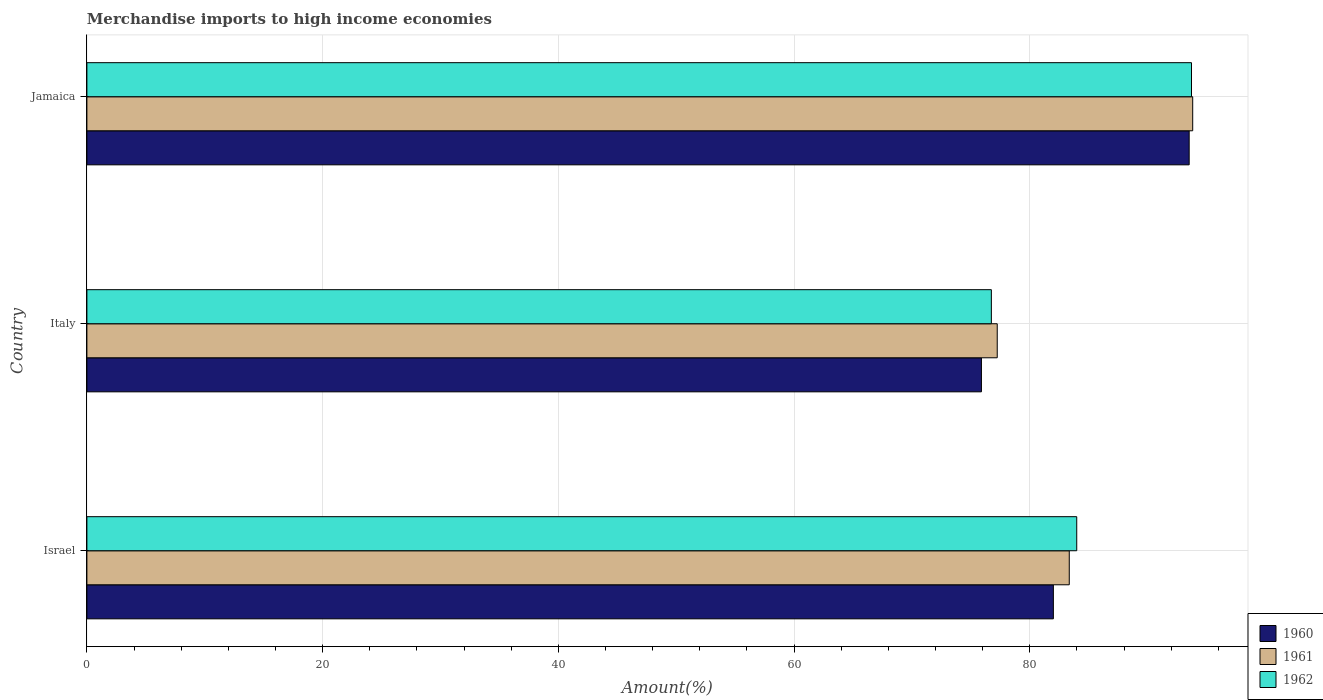How many groups of bars are there?
Offer a very short reply. 3. What is the percentage of amount earned from merchandise imports in 1961 in Israel?
Ensure brevity in your answer.  83.35. Across all countries, what is the maximum percentage of amount earned from merchandise imports in 1961?
Your answer should be compact. 93.82. Across all countries, what is the minimum percentage of amount earned from merchandise imports in 1960?
Your answer should be very brief. 75.9. In which country was the percentage of amount earned from merchandise imports in 1961 maximum?
Keep it short and to the point. Jamaica. In which country was the percentage of amount earned from merchandise imports in 1962 minimum?
Give a very brief answer. Italy. What is the total percentage of amount earned from merchandise imports in 1960 in the graph?
Your answer should be compact. 251.42. What is the difference between the percentage of amount earned from merchandise imports in 1962 in Israel and that in Jamaica?
Provide a succinct answer. -9.74. What is the difference between the percentage of amount earned from merchandise imports in 1962 in Israel and the percentage of amount earned from merchandise imports in 1960 in Jamaica?
Ensure brevity in your answer.  -9.54. What is the average percentage of amount earned from merchandise imports in 1961 per country?
Your answer should be very brief. 84.8. What is the difference between the percentage of amount earned from merchandise imports in 1962 and percentage of amount earned from merchandise imports in 1961 in Israel?
Provide a short and direct response. 0.63. What is the ratio of the percentage of amount earned from merchandise imports in 1960 in Israel to that in Italy?
Offer a terse response. 1.08. Is the percentage of amount earned from merchandise imports in 1960 in Israel less than that in Italy?
Your answer should be compact. No. What is the difference between the highest and the second highest percentage of amount earned from merchandise imports in 1962?
Keep it short and to the point. 9.74. What is the difference between the highest and the lowest percentage of amount earned from merchandise imports in 1960?
Give a very brief answer. 17.62. Is the sum of the percentage of amount earned from merchandise imports in 1960 in Italy and Jamaica greater than the maximum percentage of amount earned from merchandise imports in 1962 across all countries?
Provide a short and direct response. Yes. What does the 3rd bar from the top in Israel represents?
Keep it short and to the point. 1960. Is it the case that in every country, the sum of the percentage of amount earned from merchandise imports in 1962 and percentage of amount earned from merchandise imports in 1961 is greater than the percentage of amount earned from merchandise imports in 1960?
Your response must be concise. Yes. How many bars are there?
Ensure brevity in your answer.  9. How many countries are there in the graph?
Ensure brevity in your answer.  3. What is the difference between two consecutive major ticks on the X-axis?
Provide a succinct answer. 20. Are the values on the major ticks of X-axis written in scientific E-notation?
Ensure brevity in your answer.  No. Does the graph contain any zero values?
Give a very brief answer. No. Does the graph contain grids?
Offer a terse response. Yes. Where does the legend appear in the graph?
Offer a terse response. Bottom right. How many legend labels are there?
Give a very brief answer. 3. What is the title of the graph?
Your answer should be compact. Merchandise imports to high income economies. What is the label or title of the X-axis?
Offer a very short reply. Amount(%). What is the Amount(%) in 1960 in Israel?
Your answer should be very brief. 82. What is the Amount(%) of 1961 in Israel?
Make the answer very short. 83.35. What is the Amount(%) in 1962 in Israel?
Your answer should be compact. 83.98. What is the Amount(%) in 1960 in Italy?
Ensure brevity in your answer.  75.9. What is the Amount(%) of 1961 in Italy?
Provide a short and direct response. 77.24. What is the Amount(%) of 1962 in Italy?
Your response must be concise. 76.74. What is the Amount(%) in 1960 in Jamaica?
Provide a short and direct response. 93.52. What is the Amount(%) of 1961 in Jamaica?
Give a very brief answer. 93.82. What is the Amount(%) in 1962 in Jamaica?
Your response must be concise. 93.72. Across all countries, what is the maximum Amount(%) in 1960?
Your answer should be compact. 93.52. Across all countries, what is the maximum Amount(%) of 1961?
Give a very brief answer. 93.82. Across all countries, what is the maximum Amount(%) in 1962?
Make the answer very short. 93.72. Across all countries, what is the minimum Amount(%) of 1960?
Offer a terse response. 75.9. Across all countries, what is the minimum Amount(%) in 1961?
Offer a terse response. 77.24. Across all countries, what is the minimum Amount(%) in 1962?
Your response must be concise. 76.74. What is the total Amount(%) of 1960 in the graph?
Your response must be concise. 251.42. What is the total Amount(%) in 1961 in the graph?
Offer a terse response. 254.41. What is the total Amount(%) of 1962 in the graph?
Provide a short and direct response. 254.44. What is the difference between the Amount(%) of 1960 in Israel and that in Italy?
Your answer should be very brief. 6.1. What is the difference between the Amount(%) of 1961 in Israel and that in Italy?
Provide a short and direct response. 6.11. What is the difference between the Amount(%) in 1962 in Israel and that in Italy?
Your response must be concise. 7.24. What is the difference between the Amount(%) in 1960 in Israel and that in Jamaica?
Your response must be concise. -11.52. What is the difference between the Amount(%) in 1961 in Israel and that in Jamaica?
Keep it short and to the point. -10.47. What is the difference between the Amount(%) of 1962 in Israel and that in Jamaica?
Make the answer very short. -9.74. What is the difference between the Amount(%) of 1960 in Italy and that in Jamaica?
Give a very brief answer. -17.62. What is the difference between the Amount(%) in 1961 in Italy and that in Jamaica?
Keep it short and to the point. -16.58. What is the difference between the Amount(%) of 1962 in Italy and that in Jamaica?
Ensure brevity in your answer.  -16.98. What is the difference between the Amount(%) in 1960 in Israel and the Amount(%) in 1961 in Italy?
Give a very brief answer. 4.76. What is the difference between the Amount(%) of 1960 in Israel and the Amount(%) of 1962 in Italy?
Make the answer very short. 5.26. What is the difference between the Amount(%) in 1961 in Israel and the Amount(%) in 1962 in Italy?
Keep it short and to the point. 6.61. What is the difference between the Amount(%) of 1960 in Israel and the Amount(%) of 1961 in Jamaica?
Provide a short and direct response. -11.82. What is the difference between the Amount(%) in 1960 in Israel and the Amount(%) in 1962 in Jamaica?
Offer a very short reply. -11.72. What is the difference between the Amount(%) of 1961 in Israel and the Amount(%) of 1962 in Jamaica?
Provide a succinct answer. -10.37. What is the difference between the Amount(%) of 1960 in Italy and the Amount(%) of 1961 in Jamaica?
Provide a succinct answer. -17.92. What is the difference between the Amount(%) in 1960 in Italy and the Amount(%) in 1962 in Jamaica?
Your answer should be very brief. -17.82. What is the difference between the Amount(%) of 1961 in Italy and the Amount(%) of 1962 in Jamaica?
Make the answer very short. -16.48. What is the average Amount(%) in 1960 per country?
Provide a short and direct response. 83.81. What is the average Amount(%) in 1961 per country?
Provide a succinct answer. 84.8. What is the average Amount(%) in 1962 per country?
Provide a short and direct response. 84.81. What is the difference between the Amount(%) in 1960 and Amount(%) in 1961 in Israel?
Ensure brevity in your answer.  -1.35. What is the difference between the Amount(%) in 1960 and Amount(%) in 1962 in Israel?
Make the answer very short. -1.98. What is the difference between the Amount(%) of 1961 and Amount(%) of 1962 in Israel?
Provide a short and direct response. -0.63. What is the difference between the Amount(%) of 1960 and Amount(%) of 1961 in Italy?
Your answer should be very brief. -1.34. What is the difference between the Amount(%) of 1960 and Amount(%) of 1962 in Italy?
Offer a very short reply. -0.84. What is the difference between the Amount(%) in 1961 and Amount(%) in 1962 in Italy?
Give a very brief answer. 0.5. What is the difference between the Amount(%) of 1960 and Amount(%) of 1961 in Jamaica?
Make the answer very short. -0.3. What is the difference between the Amount(%) of 1960 and Amount(%) of 1962 in Jamaica?
Provide a succinct answer. -0.2. What is the difference between the Amount(%) in 1961 and Amount(%) in 1962 in Jamaica?
Provide a short and direct response. 0.1. What is the ratio of the Amount(%) of 1960 in Israel to that in Italy?
Provide a succinct answer. 1.08. What is the ratio of the Amount(%) in 1961 in Israel to that in Italy?
Keep it short and to the point. 1.08. What is the ratio of the Amount(%) in 1962 in Israel to that in Italy?
Your response must be concise. 1.09. What is the ratio of the Amount(%) of 1960 in Israel to that in Jamaica?
Make the answer very short. 0.88. What is the ratio of the Amount(%) of 1961 in Israel to that in Jamaica?
Make the answer very short. 0.89. What is the ratio of the Amount(%) of 1962 in Israel to that in Jamaica?
Offer a very short reply. 0.9. What is the ratio of the Amount(%) of 1960 in Italy to that in Jamaica?
Offer a very short reply. 0.81. What is the ratio of the Amount(%) in 1961 in Italy to that in Jamaica?
Ensure brevity in your answer.  0.82. What is the ratio of the Amount(%) in 1962 in Italy to that in Jamaica?
Your response must be concise. 0.82. What is the difference between the highest and the second highest Amount(%) of 1960?
Keep it short and to the point. 11.52. What is the difference between the highest and the second highest Amount(%) in 1961?
Give a very brief answer. 10.47. What is the difference between the highest and the second highest Amount(%) in 1962?
Your answer should be very brief. 9.74. What is the difference between the highest and the lowest Amount(%) of 1960?
Provide a short and direct response. 17.62. What is the difference between the highest and the lowest Amount(%) in 1961?
Provide a short and direct response. 16.58. What is the difference between the highest and the lowest Amount(%) of 1962?
Make the answer very short. 16.98. 